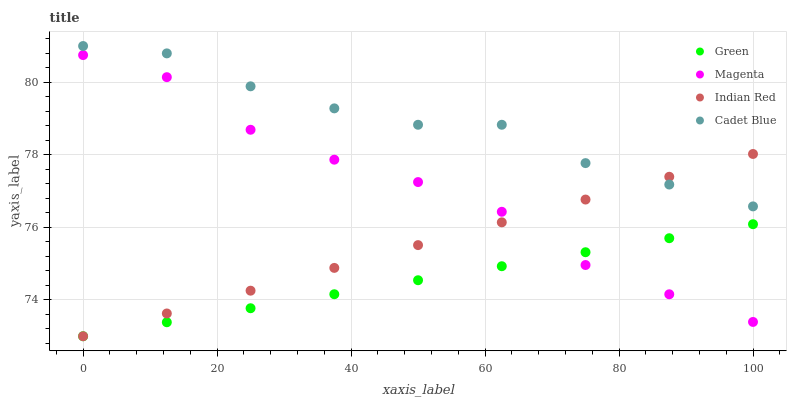Does Green have the minimum area under the curve?
Answer yes or no. Yes. Does Cadet Blue have the maximum area under the curve?
Answer yes or no. Yes. Does Cadet Blue have the minimum area under the curve?
Answer yes or no. No. Does Green have the maximum area under the curve?
Answer yes or no. No. Is Indian Red the smoothest?
Answer yes or no. Yes. Is Magenta the roughest?
Answer yes or no. Yes. Is Cadet Blue the smoothest?
Answer yes or no. No. Is Cadet Blue the roughest?
Answer yes or no. No. Does Green have the lowest value?
Answer yes or no. Yes. Does Cadet Blue have the lowest value?
Answer yes or no. No. Does Cadet Blue have the highest value?
Answer yes or no. Yes. Does Green have the highest value?
Answer yes or no. No. Is Magenta less than Cadet Blue?
Answer yes or no. Yes. Is Cadet Blue greater than Magenta?
Answer yes or no. Yes. Does Magenta intersect Indian Red?
Answer yes or no. Yes. Is Magenta less than Indian Red?
Answer yes or no. No. Is Magenta greater than Indian Red?
Answer yes or no. No. Does Magenta intersect Cadet Blue?
Answer yes or no. No. 